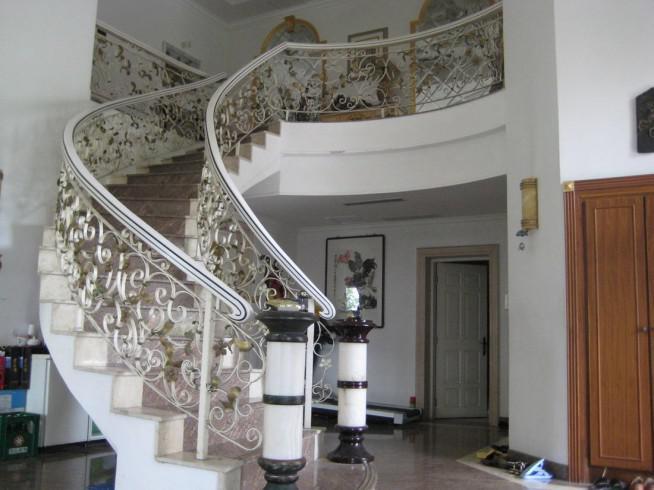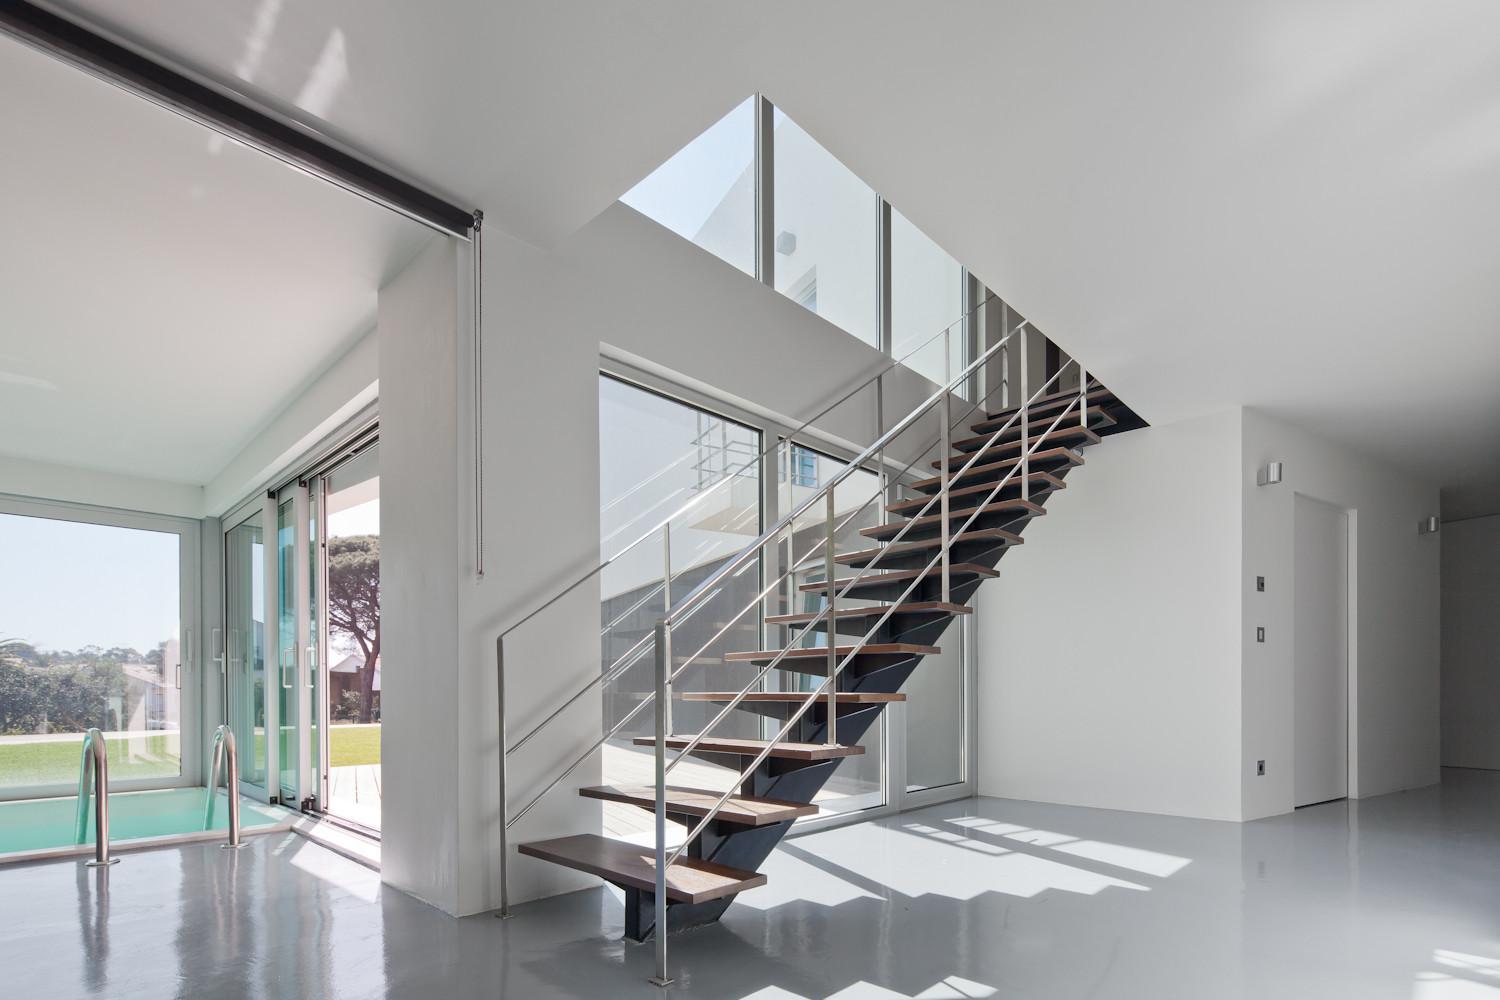The first image is the image on the left, the second image is the image on the right. For the images shown, is this caption "An image shows a side view of a staircase with an enclosed all-white side and a wooden rail with horizontal metal bars criss-crossed by wood." true? Answer yes or no. No. 